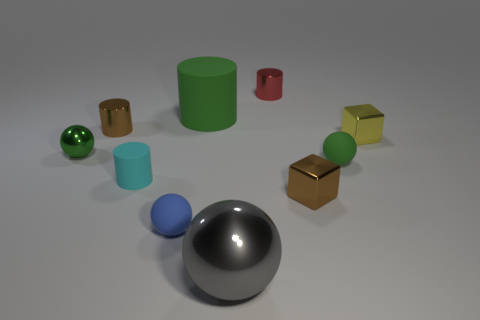Subtract all spheres. How many objects are left? 6 Add 1 small cyan matte things. How many small cyan matte things exist? 2 Subtract 1 gray balls. How many objects are left? 9 Subtract all small blue spheres. Subtract all small rubber objects. How many objects are left? 6 Add 8 large gray metallic objects. How many large gray metallic objects are left? 9 